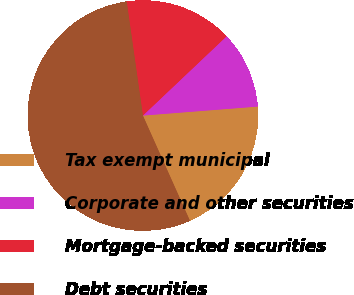Convert chart to OTSL. <chart><loc_0><loc_0><loc_500><loc_500><pie_chart><fcel>Tax exempt municipal<fcel>Corporate and other securities<fcel>Mortgage-backed securities<fcel>Debt securities<nl><fcel>19.55%<fcel>10.82%<fcel>15.18%<fcel>54.45%<nl></chart> 